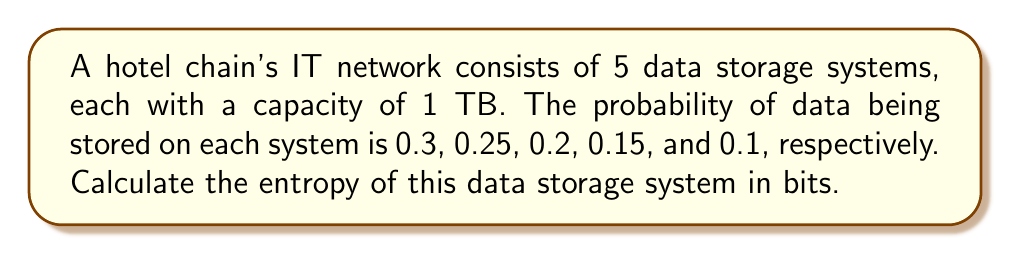Provide a solution to this math problem. To calculate the entropy of the data storage system, we'll use the Shannon entropy formula:

$$S = -\sum_{i=1}^{n} p_i \log_2(p_i)$$

Where:
$S$ is the entropy
$p_i$ is the probability of data being stored on system $i$
$n$ is the number of storage systems

Step 1: Calculate each term in the sum:
- For system 1: $-0.3 \log_2(0.3) = 0.521$
- For system 2: $-0.25 \log_2(0.25) = 0.5$
- For system 3: $-0.2 \log_2(0.2) = 0.464$
- For system 4: $-0.15 \log_2(0.15) = 0.411$
- For system 5: $-0.1 \log_2(0.1) = 0.332$

Step 2: Sum all the terms:
$$S = 0.521 + 0.5 + 0.464 + 0.411 + 0.332 = 2.228$$

Therefore, the entropy of the data storage system is approximately 2.228 bits.
Answer: 2.228 bits 